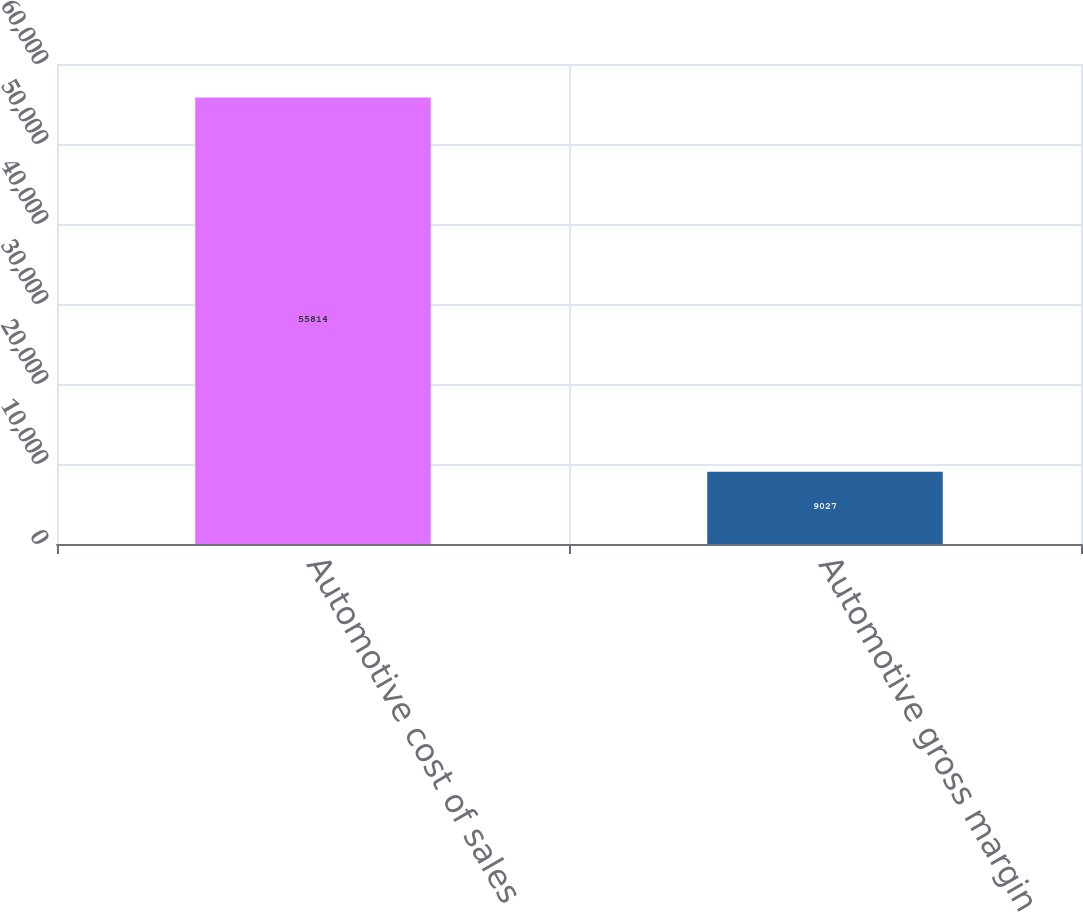Convert chart. <chart><loc_0><loc_0><loc_500><loc_500><bar_chart><fcel>Automotive cost of sales<fcel>Automotive gross margin<nl><fcel>55814<fcel>9027<nl></chart> 